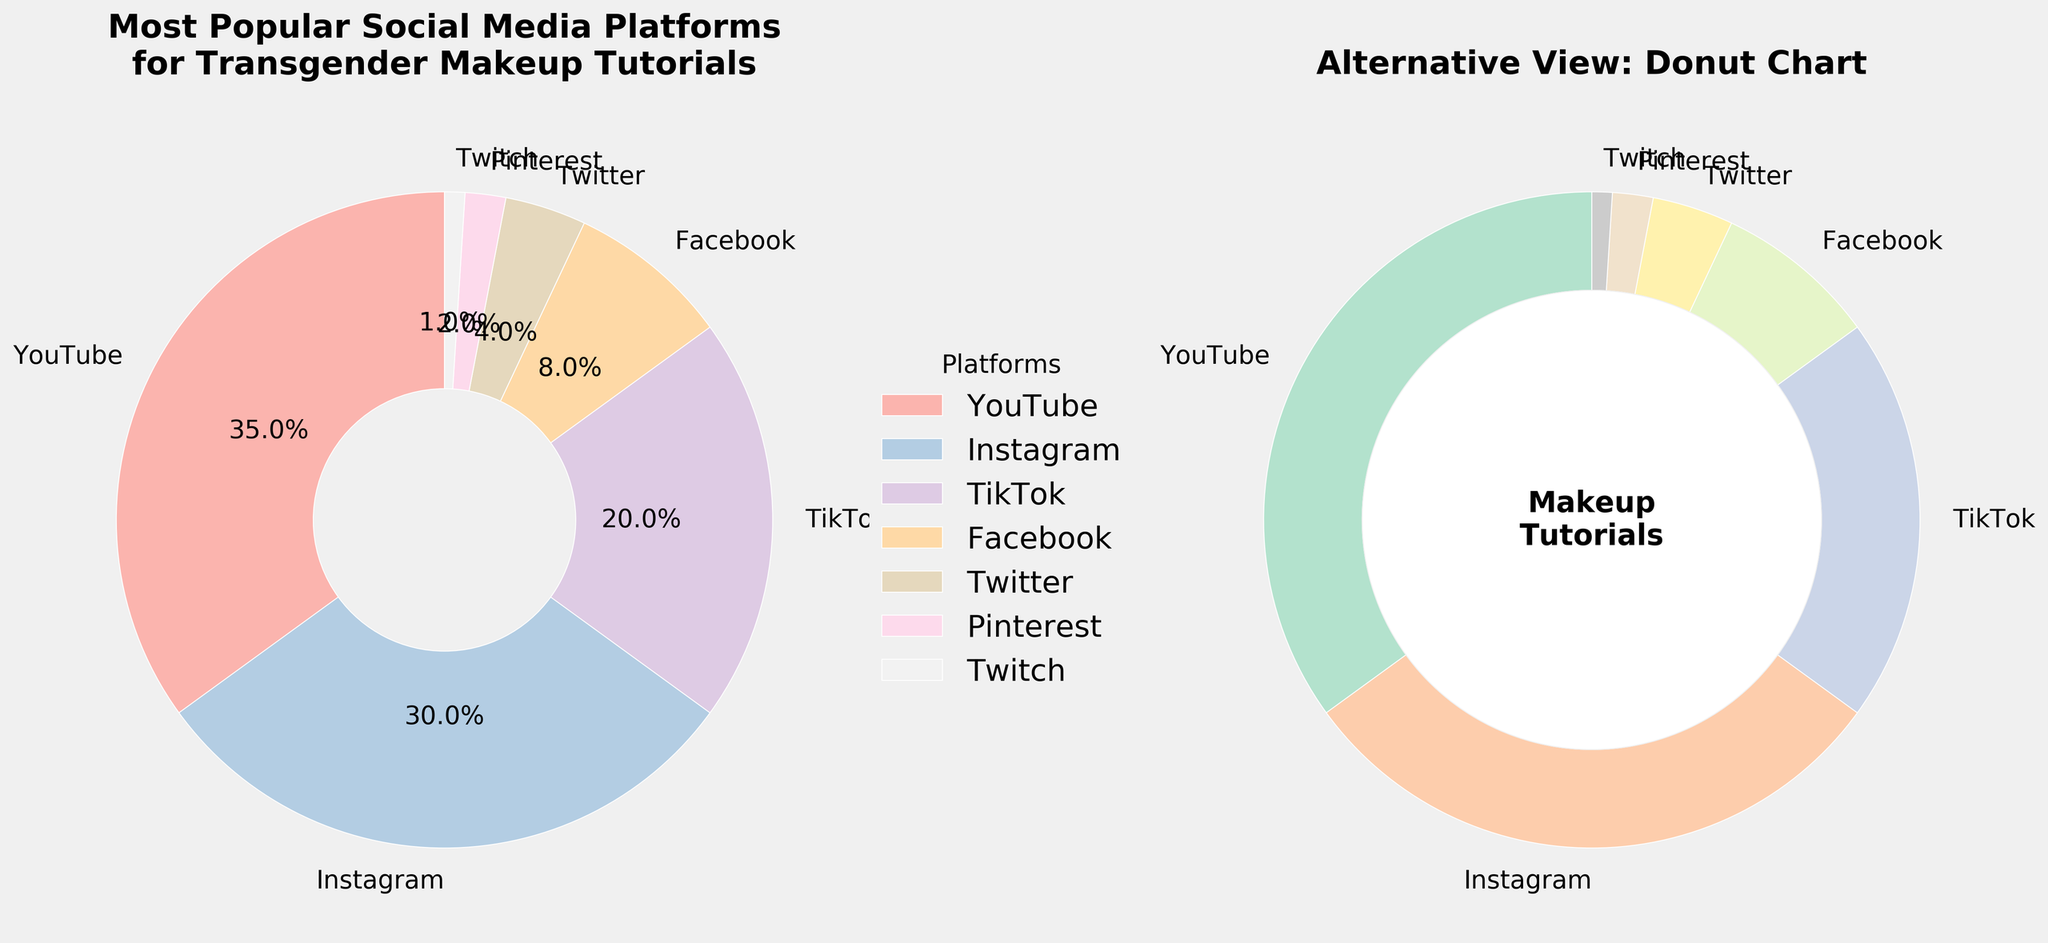What's the second most popular social media platform for transgender individuals seeking makeup tutorials? From the pie chart, the second largest segment is labeled "Instagram," occupying 30% of the chart.
Answer: Instagram Which platforms together make up nearly half of the data? Summing the percentages for the largest platforms: YouTube (35%) and Instagram (30%). 35% + 30% = 65%, which is more than half. The next set: TikTok (20%) and Facebook (8%) sums up to 28%. TikTok plus Facebook plus Twitter equals 32%, and TikTok plus Facebook sums to 28%. None make exactly half, but YouTube alone, Instagram alone, or YouTube plus TikTok make the majority alone or together
Answer: YouTube, Instagram What section is the smallest and what percentage does it represent? The pie chart shows the smallest wedge labeled "Twitch," which represents 1%.
Answer: Twitch, 1% Combine the percentages of platforms that represent less than 10% each. What is the total? Facebook (8%), Twitter (4%), Pinterest (2%), and Twitch (1%). Adding these together: 8% + 4% + 2% + 1% = 15%
Answer: 15% Which platform represents exactly one-fifth of the data? The pie chart shows TikTok, which is labeled with 20%, representing one-fifth of the total 100%.
Answer: TikTok Which color corresponds to Twitter in the donut chart, and where is it located? In the donut chart with pastel colors, Twitter is visually differentiated and located near the bottom right. The exact color might depend on the color palette mapping but is different from other colors.
Answer: Bottom right How much more popular is YouTube compared to Twitter? The percentage for YouTube is 35% and for Twitter is 4%. Subtract Twitter's percentage from YouTube's: 35% - 4% = 31%
Answer: 31% How does the combination of Instagram and TikTok compare to Facebook? Summing Instagram (30%) and TikTok (20%) gives a combined percentage of 50%, while Facebook has 8%. Thus, the combination is significantly higher.
Answer: 50% vs. 8% Which platforms combined form a majority of the data? Adding the percentages of the largest platforms sequentially until exceeding or reaching 50%. YouTube (35%) and Instagram (30%) together equate to 65%, which is a majority.
Answer: YouTube, Instagram Is the percentage of YouTube more than the combined percentage of Pinterest and Twitch? YouTube is 35%, and the combined percentage of Pinterest (2%) and Twitch (1%) is 3%. Therefore, 35% is much greater than 3%.
Answer: Yes 